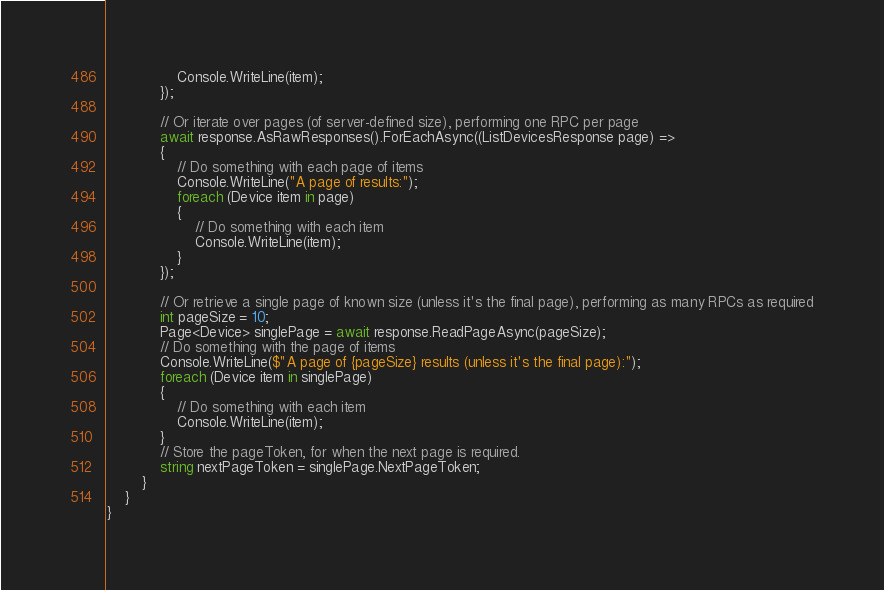<code> <loc_0><loc_0><loc_500><loc_500><_C#_>                Console.WriteLine(item);
            });

            // Or iterate over pages (of server-defined size), performing one RPC per page
            await response.AsRawResponses().ForEachAsync((ListDevicesResponse page) =>
            {
                // Do something with each page of items
                Console.WriteLine("A page of results:");
                foreach (Device item in page)
                {
                    // Do something with each item
                    Console.WriteLine(item);
                }
            });

            // Or retrieve a single page of known size (unless it's the final page), performing as many RPCs as required
            int pageSize = 10;
            Page<Device> singlePage = await response.ReadPageAsync(pageSize);
            // Do something with the page of items
            Console.WriteLine($"A page of {pageSize} results (unless it's the final page):");
            foreach (Device item in singlePage)
            {
                // Do something with each item
                Console.WriteLine(item);
            }
            // Store the pageToken, for when the next page is required.
            string nextPageToken = singlePage.NextPageToken;
        }
    }
}
</code> 